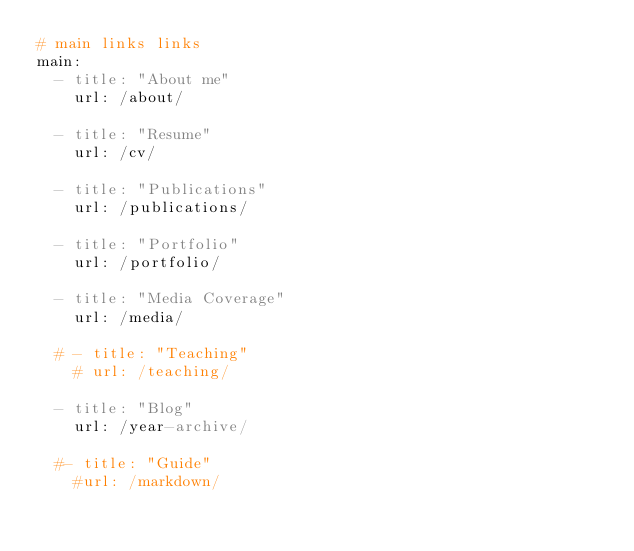<code> <loc_0><loc_0><loc_500><loc_500><_YAML_># main links links
main:
  - title: "About me"
    url: /about/

  - title: "Resume"
    url: /cv/

  - title: "Publications"
    url: /publications/
    
  - title: "Portfolio"
    url: /portfolio/
    
  - title: "Media Coverage"
    url: /media/    

  # - title: "Teaching"
    # url: /teaching/    

  - title: "Blog"
    url: /year-archive/
    
  #- title: "Guide"
    #url: /markdown/
</code> 